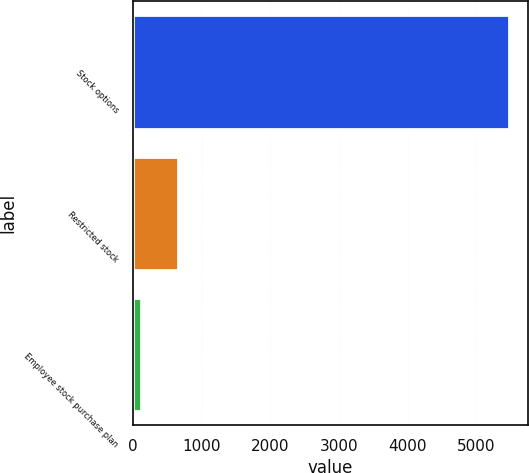Convert chart to OTSL. <chart><loc_0><loc_0><loc_500><loc_500><bar_chart><fcel>Stock options<fcel>Restricted stock<fcel>Employee stock purchase plan<nl><fcel>5477<fcel>651.2<fcel>115<nl></chart> 